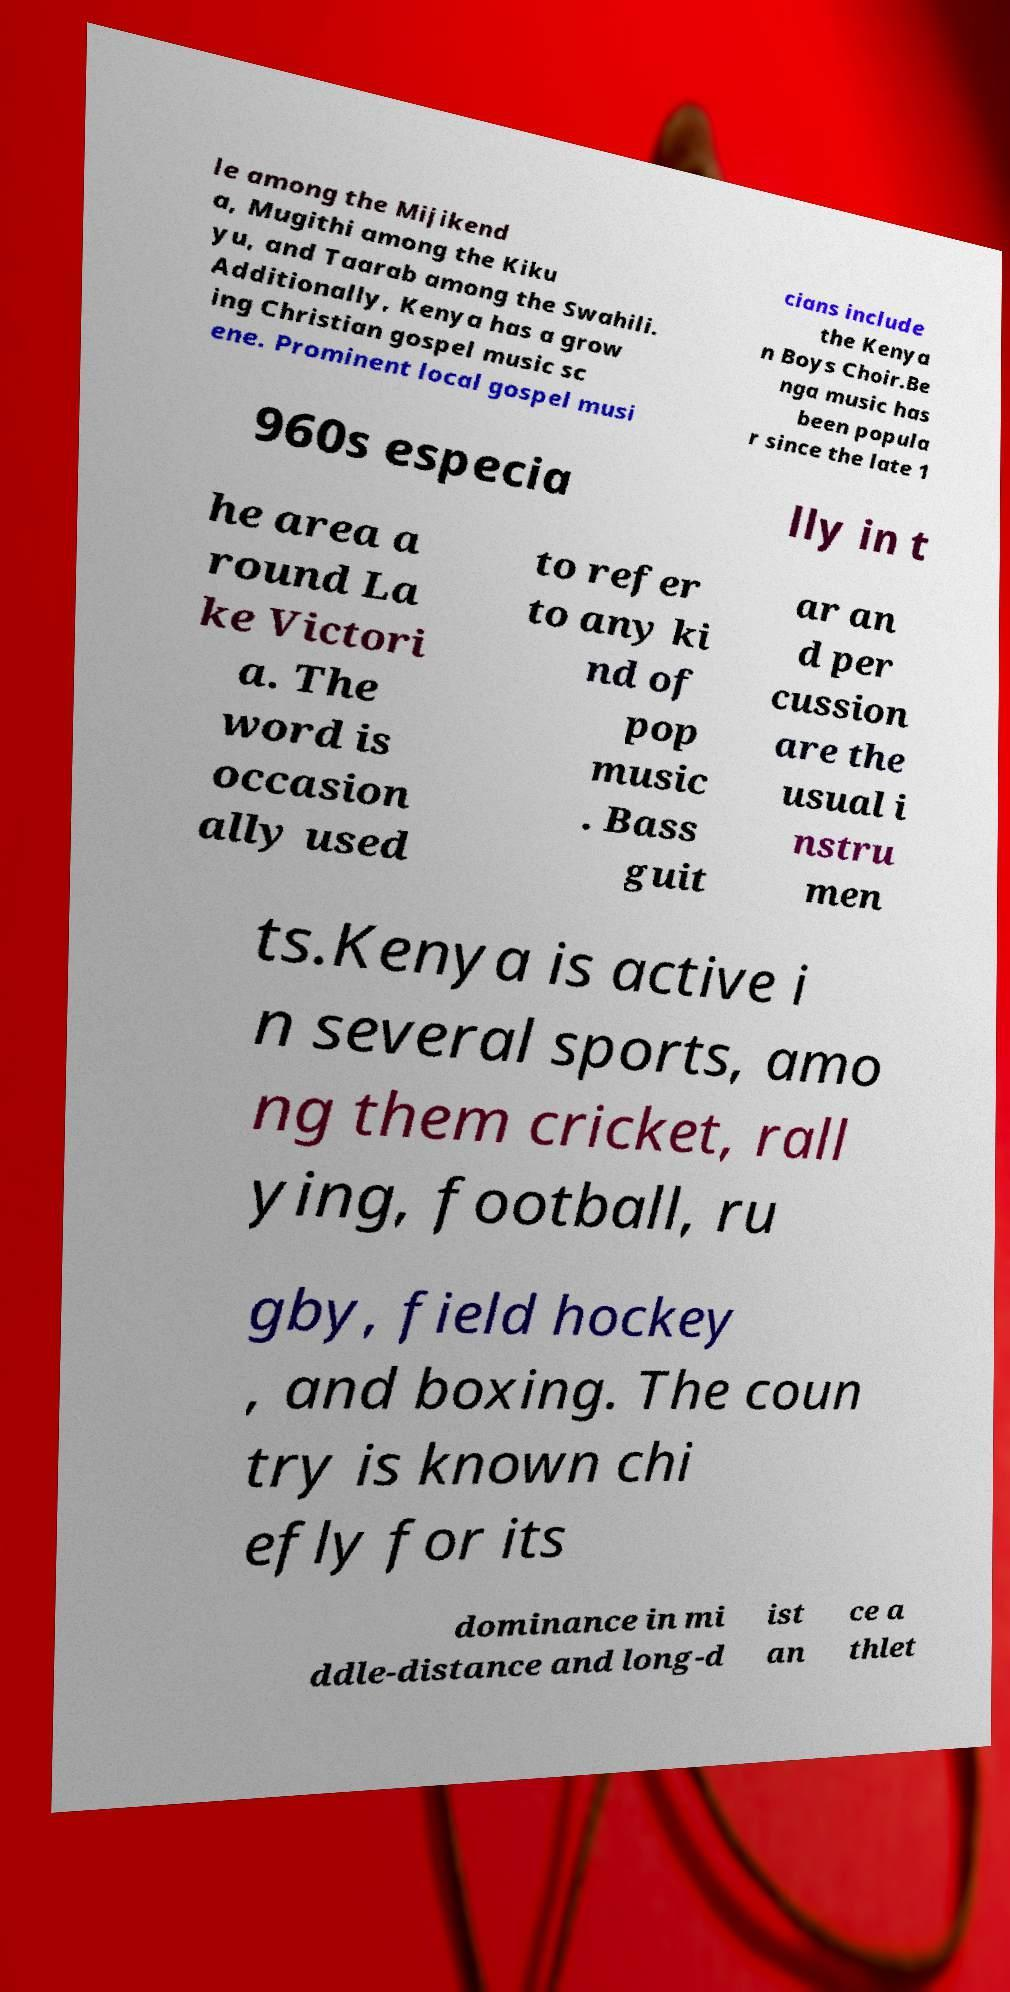There's text embedded in this image that I need extracted. Can you transcribe it verbatim? le among the Mijikend a, Mugithi among the Kiku yu, and Taarab among the Swahili. Additionally, Kenya has a grow ing Christian gospel music sc ene. Prominent local gospel musi cians include the Kenya n Boys Choir.Be nga music has been popula r since the late 1 960s especia lly in t he area a round La ke Victori a. The word is occasion ally used to refer to any ki nd of pop music . Bass guit ar an d per cussion are the usual i nstru men ts.Kenya is active i n several sports, amo ng them cricket, rall ying, football, ru gby, field hockey , and boxing. The coun try is known chi efly for its dominance in mi ddle-distance and long-d ist an ce a thlet 